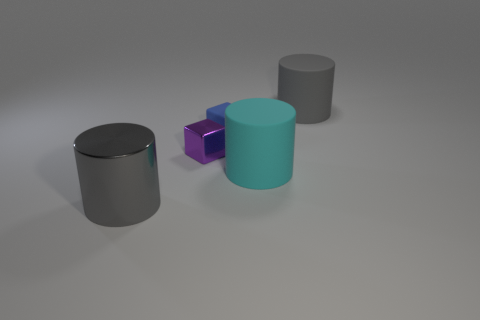Subtract all metal cylinders. How many cylinders are left? 2 Subtract all cyan balls. How many gray cylinders are left? 2 Add 1 cubes. How many objects exist? 6 Subtract 1 cylinders. How many cylinders are left? 2 Subtract all cylinders. How many objects are left? 2 Add 4 cylinders. How many cylinders exist? 7 Subtract 0 brown blocks. How many objects are left? 5 Subtract all purple blocks. Subtract all cyan cylinders. How many blocks are left? 1 Subtract all big cylinders. Subtract all tiny metallic things. How many objects are left? 1 Add 1 big gray things. How many big gray things are left? 3 